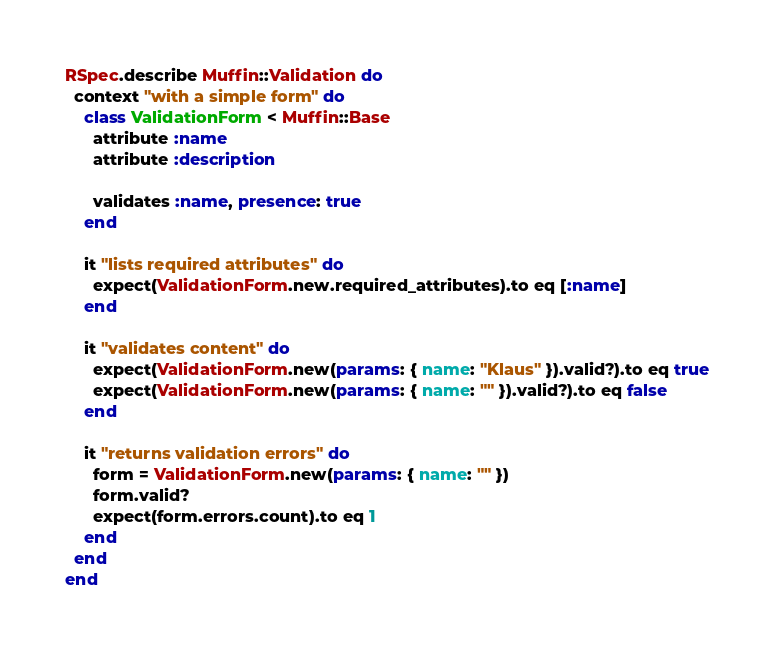<code> <loc_0><loc_0><loc_500><loc_500><_Ruby_>RSpec.describe Muffin::Validation do
  context "with a simple form" do
    class ValidationForm < Muffin::Base
      attribute :name
      attribute :description

      validates :name, presence: true
    end

    it "lists required attributes" do
      expect(ValidationForm.new.required_attributes).to eq [:name]
    end

    it "validates content" do
      expect(ValidationForm.new(params: { name: "Klaus" }).valid?).to eq true
      expect(ValidationForm.new(params: { name: "" }).valid?).to eq false
    end

    it "returns validation errors" do
      form = ValidationForm.new(params: { name: "" })
      form.valid?
      expect(form.errors.count).to eq 1
    end
  end
end
</code> 